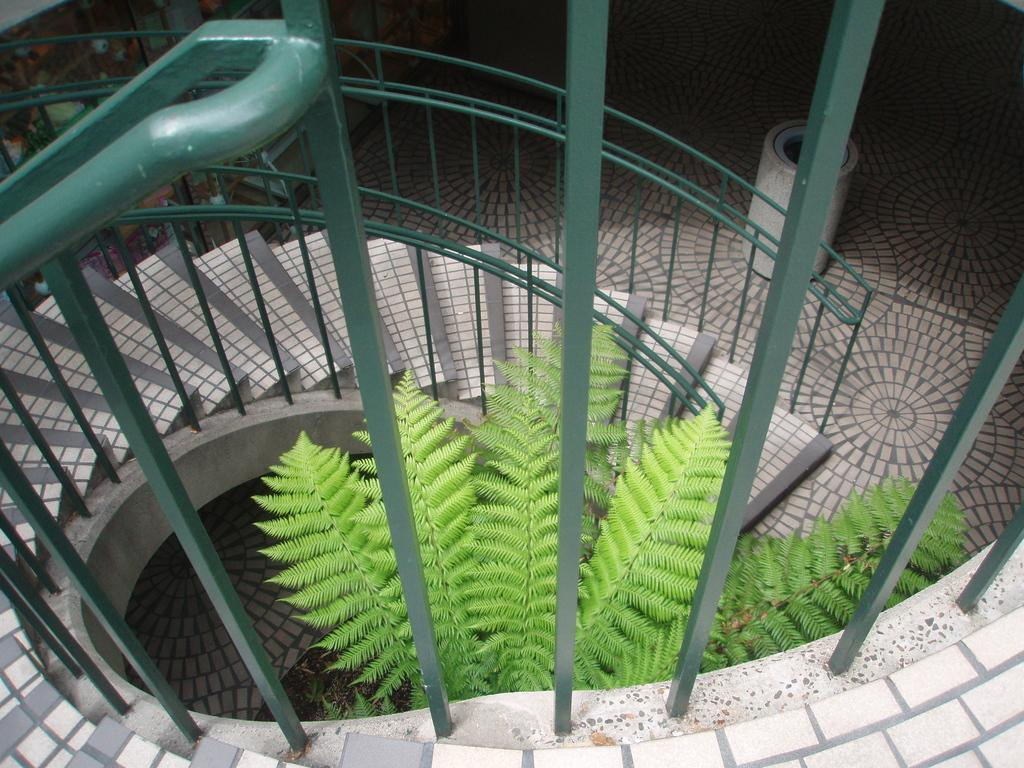What type of structure is present in the image? There are stairs in the image. Can you describe the surroundings of the stairs? There is a tree between the stairs in the image. What type of ring can be seen around the moon in the image? There is no moon or ring present in the image; it only features stairs and a tree. 